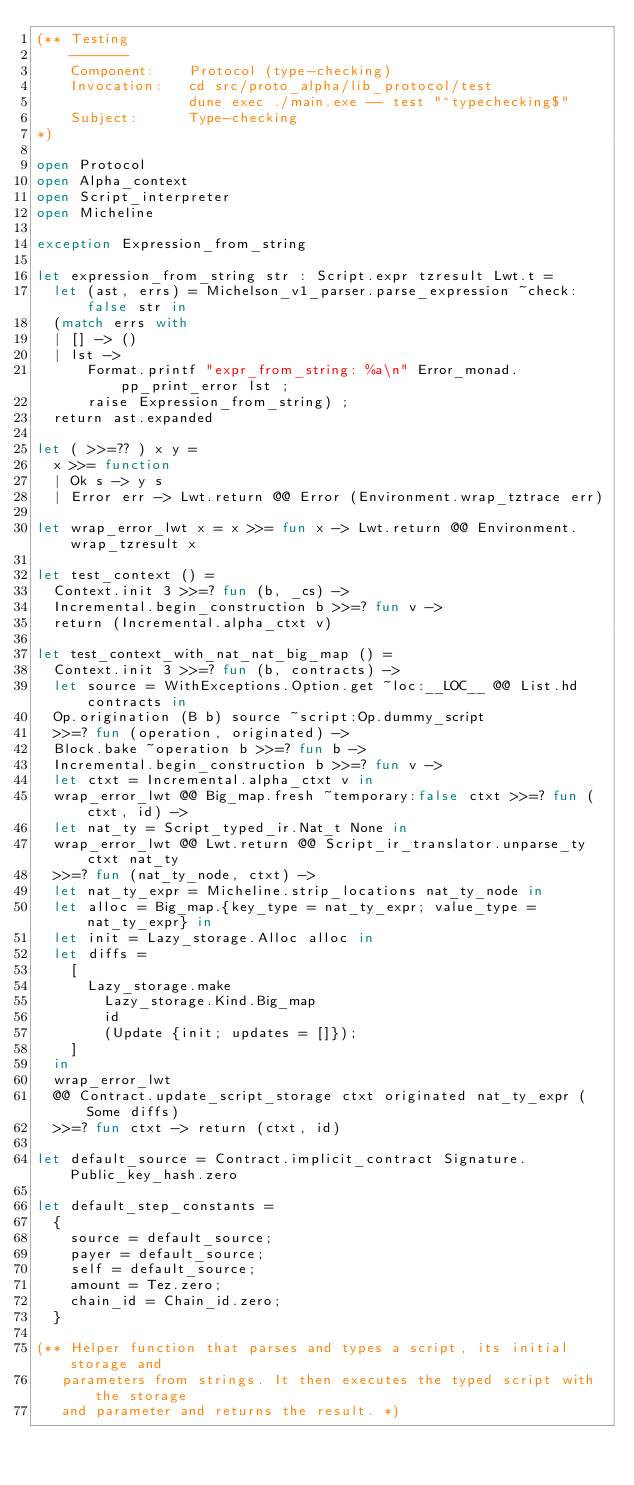Convert code to text. <code><loc_0><loc_0><loc_500><loc_500><_OCaml_>(** Testing
    -------
    Component:    Protocol (type-checking)
    Invocation:   cd src/proto_alpha/lib_protocol/test
                  dune exec ./main.exe -- test "^typechecking$"
    Subject:      Type-checking
*)

open Protocol
open Alpha_context
open Script_interpreter
open Micheline

exception Expression_from_string

let expression_from_string str : Script.expr tzresult Lwt.t =
  let (ast, errs) = Michelson_v1_parser.parse_expression ~check:false str in
  (match errs with
  | [] -> ()
  | lst ->
      Format.printf "expr_from_string: %a\n" Error_monad.pp_print_error lst ;
      raise Expression_from_string) ;
  return ast.expanded

let ( >>=?? ) x y =
  x >>= function
  | Ok s -> y s
  | Error err -> Lwt.return @@ Error (Environment.wrap_tztrace err)

let wrap_error_lwt x = x >>= fun x -> Lwt.return @@ Environment.wrap_tzresult x

let test_context () =
  Context.init 3 >>=? fun (b, _cs) ->
  Incremental.begin_construction b >>=? fun v ->
  return (Incremental.alpha_ctxt v)

let test_context_with_nat_nat_big_map () =
  Context.init 3 >>=? fun (b, contracts) ->
  let source = WithExceptions.Option.get ~loc:__LOC__ @@ List.hd contracts in
  Op.origination (B b) source ~script:Op.dummy_script
  >>=? fun (operation, originated) ->
  Block.bake ~operation b >>=? fun b ->
  Incremental.begin_construction b >>=? fun v ->
  let ctxt = Incremental.alpha_ctxt v in
  wrap_error_lwt @@ Big_map.fresh ~temporary:false ctxt >>=? fun (ctxt, id) ->
  let nat_ty = Script_typed_ir.Nat_t None in
  wrap_error_lwt @@ Lwt.return @@ Script_ir_translator.unparse_ty ctxt nat_ty
  >>=? fun (nat_ty_node, ctxt) ->
  let nat_ty_expr = Micheline.strip_locations nat_ty_node in
  let alloc = Big_map.{key_type = nat_ty_expr; value_type = nat_ty_expr} in
  let init = Lazy_storage.Alloc alloc in
  let diffs =
    [
      Lazy_storage.make
        Lazy_storage.Kind.Big_map
        id
        (Update {init; updates = []});
    ]
  in
  wrap_error_lwt
  @@ Contract.update_script_storage ctxt originated nat_ty_expr (Some diffs)
  >>=? fun ctxt -> return (ctxt, id)

let default_source = Contract.implicit_contract Signature.Public_key_hash.zero

let default_step_constants =
  {
    source = default_source;
    payer = default_source;
    self = default_source;
    amount = Tez.zero;
    chain_id = Chain_id.zero;
  }

(** Helper function that parses and types a script, its initial storage and
   parameters from strings. It then executes the typed script with the storage
   and parameter and returns the result. *)</code> 